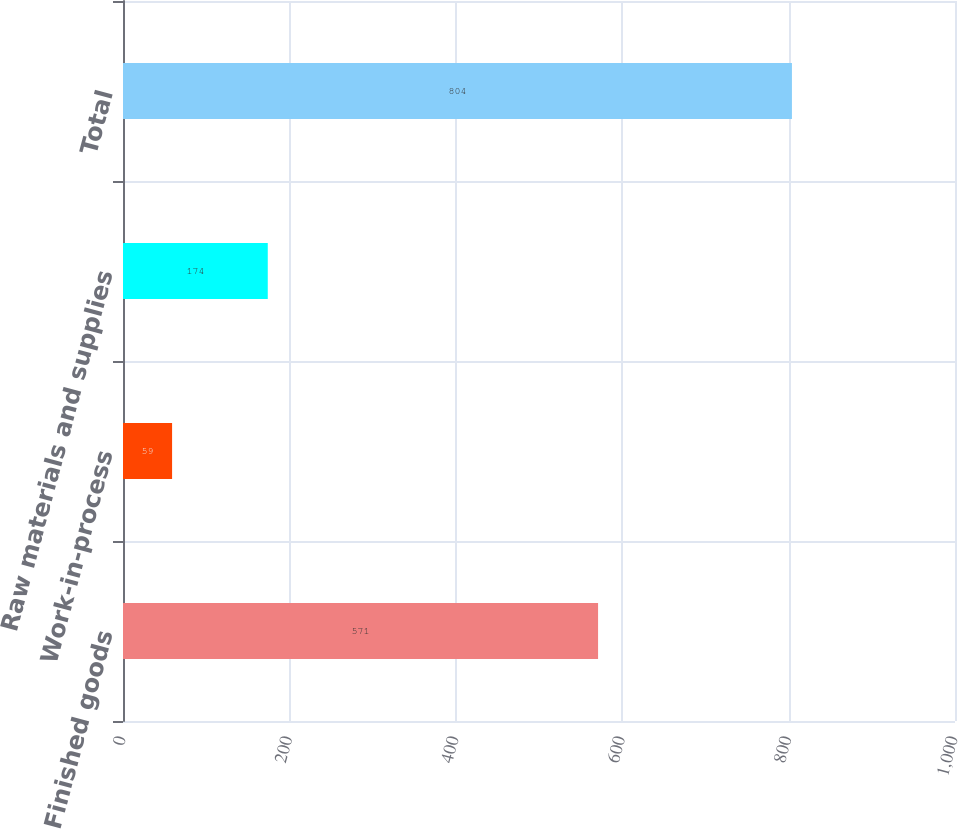Convert chart. <chart><loc_0><loc_0><loc_500><loc_500><bar_chart><fcel>Finished goods<fcel>Work-in-process<fcel>Raw materials and supplies<fcel>Total<nl><fcel>571<fcel>59<fcel>174<fcel>804<nl></chart> 